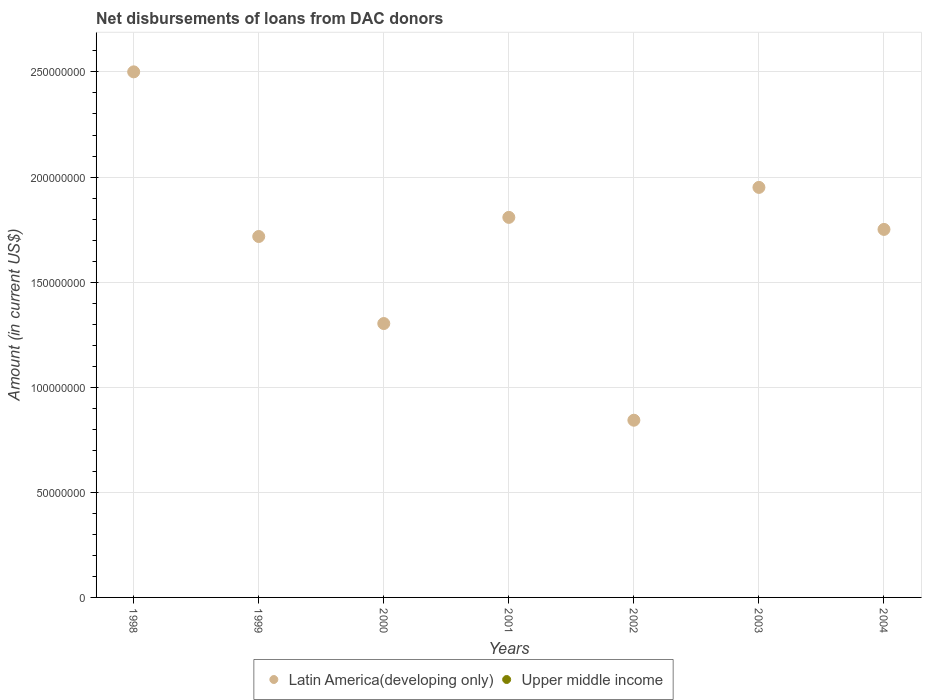Is the number of dotlines equal to the number of legend labels?
Offer a terse response. No. What is the amount of loans disbursed in Upper middle income in 1999?
Make the answer very short. 0. Across all years, what is the maximum amount of loans disbursed in Latin America(developing only)?
Your response must be concise. 2.50e+08. Across all years, what is the minimum amount of loans disbursed in Latin America(developing only)?
Offer a very short reply. 8.43e+07. What is the total amount of loans disbursed in Latin America(developing only) in the graph?
Give a very brief answer. 1.19e+09. What is the difference between the amount of loans disbursed in Latin America(developing only) in 2001 and that in 2002?
Offer a very short reply. 9.65e+07. What is the difference between the amount of loans disbursed in Upper middle income in 2003 and the amount of loans disbursed in Latin America(developing only) in 2001?
Your response must be concise. -1.81e+08. What is the average amount of loans disbursed in Latin America(developing only) per year?
Provide a short and direct response. 1.70e+08. In how many years, is the amount of loans disbursed in Latin America(developing only) greater than 110000000 US$?
Your answer should be compact. 6. What is the ratio of the amount of loans disbursed in Latin America(developing only) in 1999 to that in 2004?
Keep it short and to the point. 0.98. Is the amount of loans disbursed in Latin America(developing only) in 1998 less than that in 2004?
Offer a very short reply. No. What is the difference between the highest and the second highest amount of loans disbursed in Latin America(developing only)?
Keep it short and to the point. 5.50e+07. What is the difference between the highest and the lowest amount of loans disbursed in Latin America(developing only)?
Provide a short and direct response. 1.66e+08. In how many years, is the amount of loans disbursed in Upper middle income greater than the average amount of loans disbursed in Upper middle income taken over all years?
Keep it short and to the point. 0. Is the sum of the amount of loans disbursed in Latin America(developing only) in 2000 and 2003 greater than the maximum amount of loans disbursed in Upper middle income across all years?
Ensure brevity in your answer.  Yes. Does the amount of loans disbursed in Upper middle income monotonically increase over the years?
Make the answer very short. No. Is the amount of loans disbursed in Latin America(developing only) strictly less than the amount of loans disbursed in Upper middle income over the years?
Offer a terse response. No. How many dotlines are there?
Give a very brief answer. 1. How many years are there in the graph?
Provide a succinct answer. 7. Are the values on the major ticks of Y-axis written in scientific E-notation?
Ensure brevity in your answer.  No. Does the graph contain grids?
Your response must be concise. Yes. How many legend labels are there?
Your answer should be compact. 2. How are the legend labels stacked?
Your answer should be very brief. Horizontal. What is the title of the graph?
Make the answer very short. Net disbursements of loans from DAC donors. Does "Micronesia" appear as one of the legend labels in the graph?
Keep it short and to the point. No. What is the Amount (in current US$) in Latin America(developing only) in 1998?
Keep it short and to the point. 2.50e+08. What is the Amount (in current US$) in Upper middle income in 1998?
Offer a terse response. 0. What is the Amount (in current US$) in Latin America(developing only) in 1999?
Keep it short and to the point. 1.72e+08. What is the Amount (in current US$) of Upper middle income in 1999?
Give a very brief answer. 0. What is the Amount (in current US$) in Latin America(developing only) in 2000?
Make the answer very short. 1.30e+08. What is the Amount (in current US$) of Upper middle income in 2000?
Your answer should be compact. 0. What is the Amount (in current US$) in Latin America(developing only) in 2001?
Provide a succinct answer. 1.81e+08. What is the Amount (in current US$) of Upper middle income in 2001?
Your response must be concise. 0. What is the Amount (in current US$) in Latin America(developing only) in 2002?
Offer a very short reply. 8.43e+07. What is the Amount (in current US$) of Upper middle income in 2002?
Keep it short and to the point. 0. What is the Amount (in current US$) in Latin America(developing only) in 2003?
Your answer should be very brief. 1.95e+08. What is the Amount (in current US$) of Latin America(developing only) in 2004?
Your answer should be compact. 1.75e+08. What is the Amount (in current US$) of Upper middle income in 2004?
Give a very brief answer. 0. Across all years, what is the maximum Amount (in current US$) of Latin America(developing only)?
Offer a very short reply. 2.50e+08. Across all years, what is the minimum Amount (in current US$) of Latin America(developing only)?
Offer a terse response. 8.43e+07. What is the total Amount (in current US$) in Latin America(developing only) in the graph?
Offer a terse response. 1.19e+09. What is the difference between the Amount (in current US$) in Latin America(developing only) in 1998 and that in 1999?
Your answer should be compact. 7.83e+07. What is the difference between the Amount (in current US$) of Latin America(developing only) in 1998 and that in 2000?
Offer a very short reply. 1.20e+08. What is the difference between the Amount (in current US$) in Latin America(developing only) in 1998 and that in 2001?
Your answer should be very brief. 6.92e+07. What is the difference between the Amount (in current US$) of Latin America(developing only) in 1998 and that in 2002?
Offer a terse response. 1.66e+08. What is the difference between the Amount (in current US$) in Latin America(developing only) in 1998 and that in 2003?
Ensure brevity in your answer.  5.50e+07. What is the difference between the Amount (in current US$) of Latin America(developing only) in 1998 and that in 2004?
Your response must be concise. 7.50e+07. What is the difference between the Amount (in current US$) in Latin America(developing only) in 1999 and that in 2000?
Offer a very short reply. 4.14e+07. What is the difference between the Amount (in current US$) in Latin America(developing only) in 1999 and that in 2001?
Keep it short and to the point. -9.10e+06. What is the difference between the Amount (in current US$) in Latin America(developing only) in 1999 and that in 2002?
Provide a succinct answer. 8.74e+07. What is the difference between the Amount (in current US$) of Latin America(developing only) in 1999 and that in 2003?
Make the answer very short. -2.34e+07. What is the difference between the Amount (in current US$) in Latin America(developing only) in 1999 and that in 2004?
Your answer should be compact. -3.37e+06. What is the difference between the Amount (in current US$) of Latin America(developing only) in 2000 and that in 2001?
Your answer should be compact. -5.05e+07. What is the difference between the Amount (in current US$) in Latin America(developing only) in 2000 and that in 2002?
Give a very brief answer. 4.60e+07. What is the difference between the Amount (in current US$) in Latin America(developing only) in 2000 and that in 2003?
Offer a very short reply. -6.48e+07. What is the difference between the Amount (in current US$) of Latin America(developing only) in 2000 and that in 2004?
Your response must be concise. -4.48e+07. What is the difference between the Amount (in current US$) in Latin America(developing only) in 2001 and that in 2002?
Your answer should be compact. 9.65e+07. What is the difference between the Amount (in current US$) in Latin America(developing only) in 2001 and that in 2003?
Keep it short and to the point. -1.43e+07. What is the difference between the Amount (in current US$) in Latin America(developing only) in 2001 and that in 2004?
Keep it short and to the point. 5.72e+06. What is the difference between the Amount (in current US$) in Latin America(developing only) in 2002 and that in 2003?
Make the answer very short. -1.11e+08. What is the difference between the Amount (in current US$) of Latin America(developing only) in 2002 and that in 2004?
Offer a terse response. -9.08e+07. What is the difference between the Amount (in current US$) of Latin America(developing only) in 2003 and that in 2004?
Give a very brief answer. 2.00e+07. What is the average Amount (in current US$) in Latin America(developing only) per year?
Provide a succinct answer. 1.70e+08. What is the average Amount (in current US$) of Upper middle income per year?
Your answer should be compact. 0. What is the ratio of the Amount (in current US$) of Latin America(developing only) in 1998 to that in 1999?
Provide a short and direct response. 1.46. What is the ratio of the Amount (in current US$) in Latin America(developing only) in 1998 to that in 2000?
Your answer should be compact. 1.92. What is the ratio of the Amount (in current US$) in Latin America(developing only) in 1998 to that in 2001?
Your response must be concise. 1.38. What is the ratio of the Amount (in current US$) of Latin America(developing only) in 1998 to that in 2002?
Ensure brevity in your answer.  2.97. What is the ratio of the Amount (in current US$) in Latin America(developing only) in 1998 to that in 2003?
Offer a very short reply. 1.28. What is the ratio of the Amount (in current US$) in Latin America(developing only) in 1998 to that in 2004?
Your answer should be compact. 1.43. What is the ratio of the Amount (in current US$) in Latin America(developing only) in 1999 to that in 2000?
Your answer should be compact. 1.32. What is the ratio of the Amount (in current US$) of Latin America(developing only) in 1999 to that in 2001?
Provide a succinct answer. 0.95. What is the ratio of the Amount (in current US$) in Latin America(developing only) in 1999 to that in 2002?
Your response must be concise. 2.04. What is the ratio of the Amount (in current US$) of Latin America(developing only) in 1999 to that in 2003?
Ensure brevity in your answer.  0.88. What is the ratio of the Amount (in current US$) in Latin America(developing only) in 1999 to that in 2004?
Ensure brevity in your answer.  0.98. What is the ratio of the Amount (in current US$) of Latin America(developing only) in 2000 to that in 2001?
Provide a short and direct response. 0.72. What is the ratio of the Amount (in current US$) in Latin America(developing only) in 2000 to that in 2002?
Give a very brief answer. 1.55. What is the ratio of the Amount (in current US$) in Latin America(developing only) in 2000 to that in 2003?
Ensure brevity in your answer.  0.67. What is the ratio of the Amount (in current US$) of Latin America(developing only) in 2000 to that in 2004?
Give a very brief answer. 0.74. What is the ratio of the Amount (in current US$) in Latin America(developing only) in 2001 to that in 2002?
Your response must be concise. 2.14. What is the ratio of the Amount (in current US$) in Latin America(developing only) in 2001 to that in 2003?
Make the answer very short. 0.93. What is the ratio of the Amount (in current US$) in Latin America(developing only) in 2001 to that in 2004?
Your response must be concise. 1.03. What is the ratio of the Amount (in current US$) of Latin America(developing only) in 2002 to that in 2003?
Make the answer very short. 0.43. What is the ratio of the Amount (in current US$) in Latin America(developing only) in 2002 to that in 2004?
Ensure brevity in your answer.  0.48. What is the ratio of the Amount (in current US$) in Latin America(developing only) in 2003 to that in 2004?
Give a very brief answer. 1.11. What is the difference between the highest and the second highest Amount (in current US$) of Latin America(developing only)?
Make the answer very short. 5.50e+07. What is the difference between the highest and the lowest Amount (in current US$) in Latin America(developing only)?
Your answer should be very brief. 1.66e+08. 